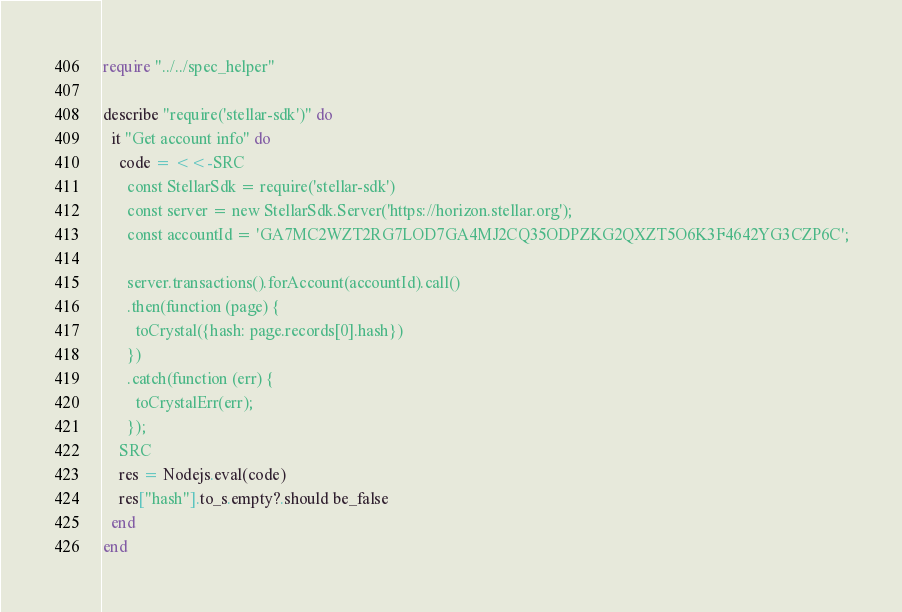Convert code to text. <code><loc_0><loc_0><loc_500><loc_500><_Crystal_>require "../../spec_helper"

describe "require('stellar-sdk')" do
  it "Get account info" do
    code = <<-SRC
      const StellarSdk = require('stellar-sdk')
      const server = new StellarSdk.Server('https://horizon.stellar.org');
      const accountId = 'GA7MC2WZT2RG7LOD7GA4MJ2CQ35ODPZKG2QXZT5O6K3F4642YG3CZP6C';

      server.transactions().forAccount(accountId).call()
      .then(function (page) {
        toCrystal({hash: page.records[0].hash})
      })
      .catch(function (err) {
        toCrystalErr(err);
      });
    SRC
    res = Nodejs.eval(code)
    res["hash"].to_s.empty?.should be_false
  end
end
</code> 